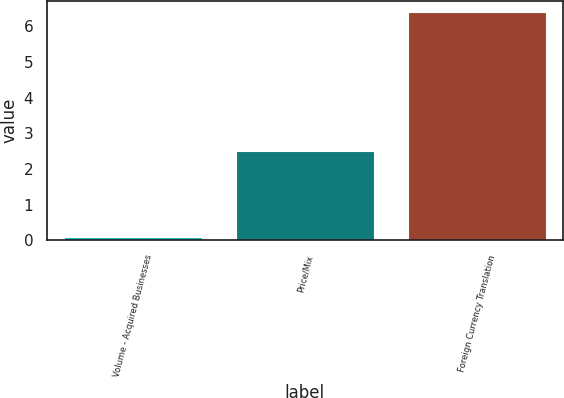Convert chart. <chart><loc_0><loc_0><loc_500><loc_500><bar_chart><fcel>Volume - Acquired Businesses<fcel>Price/Mix<fcel>Foreign Currency Translation<nl><fcel>0.1<fcel>2.5<fcel>6.4<nl></chart> 